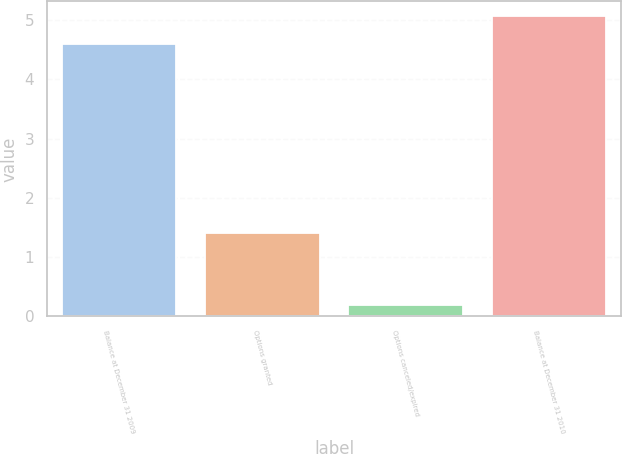Convert chart to OTSL. <chart><loc_0><loc_0><loc_500><loc_500><bar_chart><fcel>Balance at December 31 2009<fcel>Options granted<fcel>Options canceled/expired<fcel>Balance at December 31 2010<nl><fcel>4.6<fcel>1.4<fcel>0.2<fcel>5.06<nl></chart> 